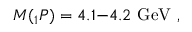Convert formula to latex. <formula><loc_0><loc_0><loc_500><loc_500>M _ { 1 } P ) = 4 . 1 - 4 . 2 \ G e V \ ,</formula> 